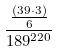Convert formula to latex. <formula><loc_0><loc_0><loc_500><loc_500>\frac { \frac { ( 3 9 \cdot 3 ) } { 6 } } { 1 8 9 ^ { 2 2 0 } }</formula> 